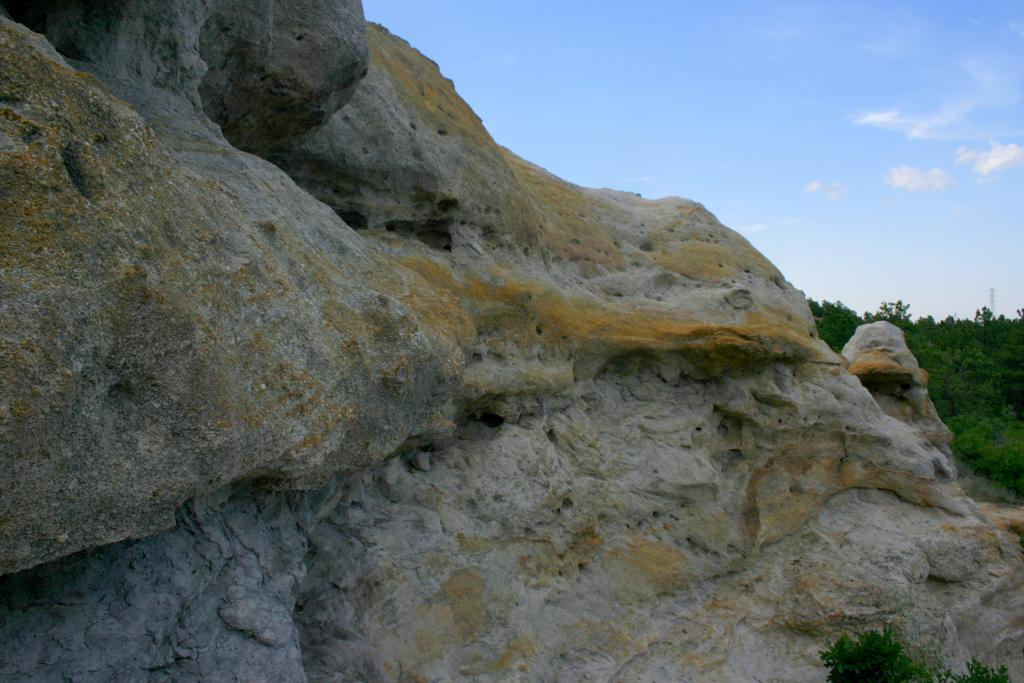What type of natural elements can be seen in the image? There are rocks in the image. What is visible in the background of the image? There is sky and trees visible in the background of the image. What type of government is being discussed in the image? There is no discussion of government in the image; it features rocks, sky, and trees. Can you tell me how many wrens are perched on the rocks in the image? There are no wrens present in the image; it features rocks, sky, and trees. 